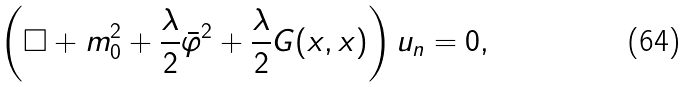<formula> <loc_0><loc_0><loc_500><loc_500>\left ( \Box + m _ { 0 } ^ { 2 } + \frac { \lambda } { 2 } \bar { \varphi } ^ { 2 } + \frac { \lambda } { 2 } G ( { x } , { x } ) \right ) u _ { n } = 0 ,</formula> 